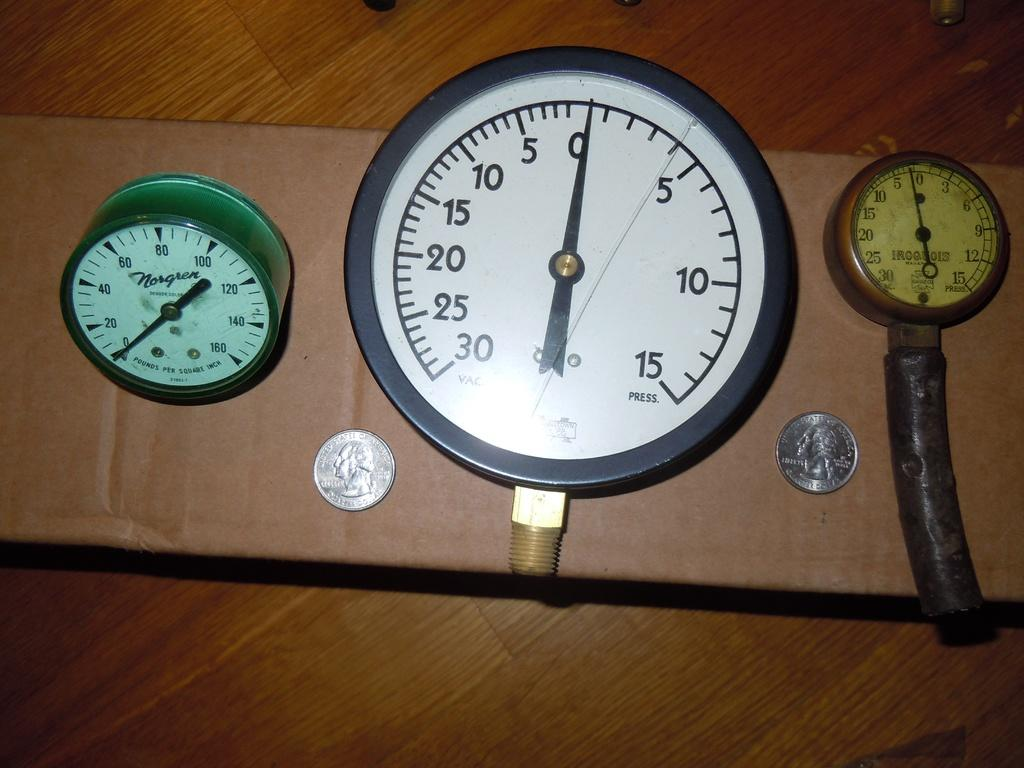<image>
Write a terse but informative summary of the picture. Three different blood pressure gauges, one made by Norgren and one made by Iroquois. 